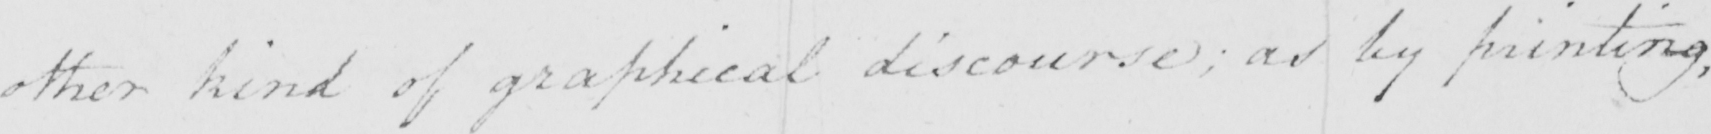Please transcribe the handwritten text in this image. other kind of graphical discourse :  as by printing , 